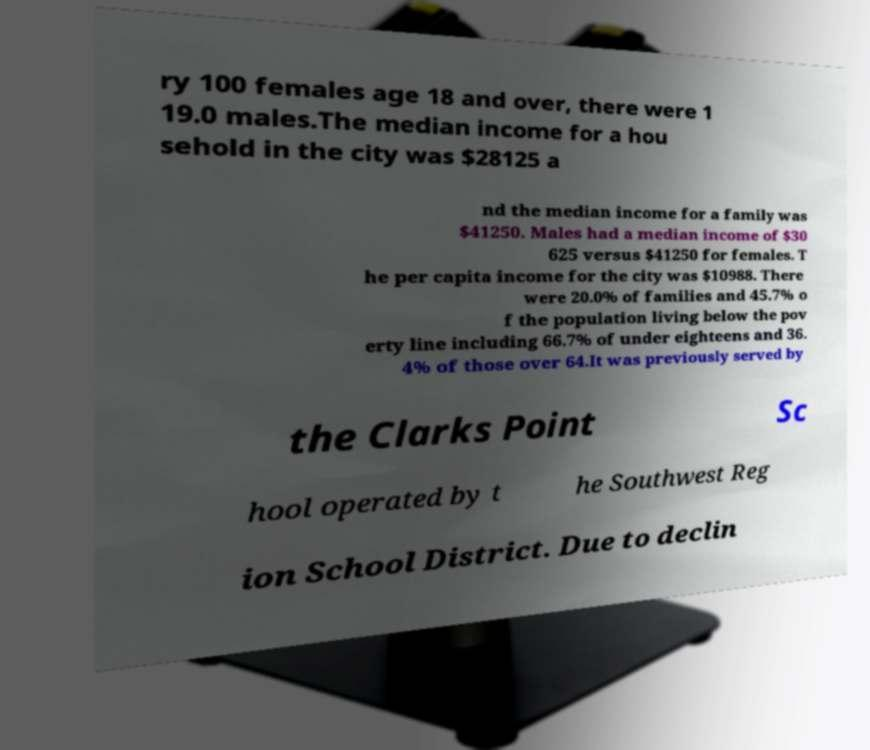Could you extract and type out the text from this image? ry 100 females age 18 and over, there were 1 19.0 males.The median income for a hou sehold in the city was $28125 a nd the median income for a family was $41250. Males had a median income of $30 625 versus $41250 for females. T he per capita income for the city was $10988. There were 20.0% of families and 45.7% o f the population living below the pov erty line including 66.7% of under eighteens and 36. 4% of those over 64.It was previously served by the Clarks Point Sc hool operated by t he Southwest Reg ion School District. Due to declin 